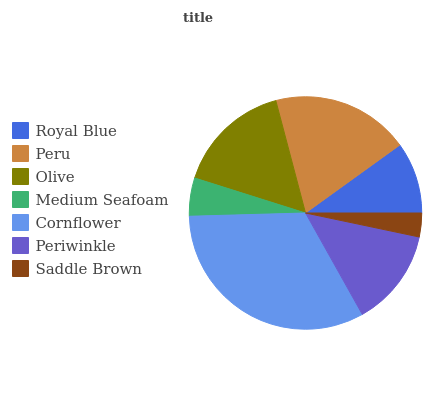Is Saddle Brown the minimum?
Answer yes or no. Yes. Is Cornflower the maximum?
Answer yes or no. Yes. Is Peru the minimum?
Answer yes or no. No. Is Peru the maximum?
Answer yes or no. No. Is Peru greater than Royal Blue?
Answer yes or no. Yes. Is Royal Blue less than Peru?
Answer yes or no. Yes. Is Royal Blue greater than Peru?
Answer yes or no. No. Is Peru less than Royal Blue?
Answer yes or no. No. Is Periwinkle the high median?
Answer yes or no. Yes. Is Periwinkle the low median?
Answer yes or no. Yes. Is Cornflower the high median?
Answer yes or no. No. Is Saddle Brown the low median?
Answer yes or no. No. 